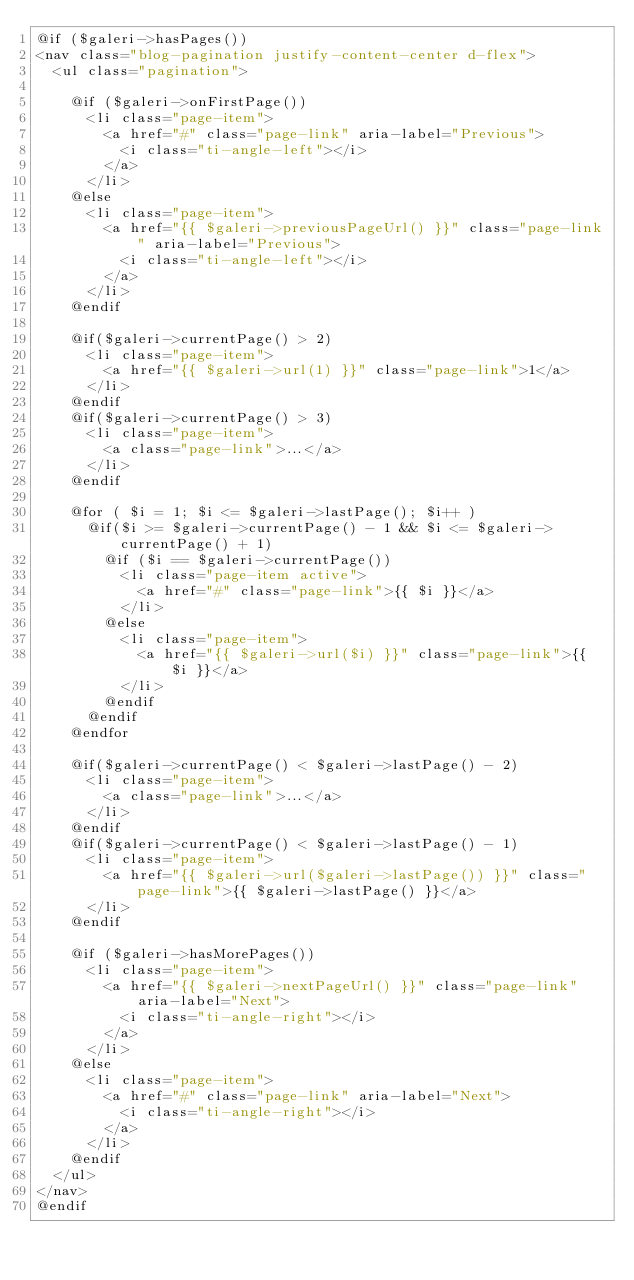<code> <loc_0><loc_0><loc_500><loc_500><_PHP_>@if ($galeri->hasPages())
<nav class="blog-pagination justify-content-center d-flex">
  <ul class="pagination">

    @if ($galeri->onFirstPage())
      <li class="page-item">
        <a href="#" class="page-link" aria-label="Previous">
          <i class="ti-angle-left"></i>
        </a>
      </li>
    @else
      <li class="page-item">
        <a href="{{ $galeri->previousPageUrl() }}" class="page-link" aria-label="Previous">
          <i class="ti-angle-left"></i>
        </a>
      </li>
    @endif

    @if($galeri->currentPage() > 2)
      <li class="page-item">
        <a href="{{ $galeri->url(1) }}" class="page-link">1</a>
      </li>
    @endif
    @if($galeri->currentPage() > 3)
      <li class="page-item">
        <a class="page-link">...</a>
      </li>
    @endif

    @for ( $i = 1; $i <= $galeri->lastPage(); $i++ )
      @if($i >= $galeri->currentPage() - 1 && $i <= $galeri->currentPage() + 1)
        @if ($i == $galeri->currentPage())
          <li class="page-item active">
            <a href="#" class="page-link">{{ $i }}</a>
          </li>
        @else
          <li class="page-item">
            <a href="{{ $galeri->url($i) }}" class="page-link">{{ $i }}</a>
          </li>
        @endif
      @endif
    @endfor

    @if($galeri->currentPage() < $galeri->lastPage() - 2)
      <li class="page-item">
        <a class="page-link">...</a>
      </li>
    @endif
    @if($galeri->currentPage() < $galeri->lastPage() - 1)
      <li class="page-item">
        <a href="{{ $galeri->url($galeri->lastPage()) }}" class="page-link">{{ $galeri->lastPage() }}</a>
      </li>
    @endif

    @if ($galeri->hasMorePages())
      <li class="page-item">
        <a href="{{ $galeri->nextPageUrl() }}" class="page-link" aria-label="Next">
          <i class="ti-angle-right"></i>
        </a>
      </li>
    @else
      <li class="page-item">
        <a href="#" class="page-link" aria-label="Next">
          <i class="ti-angle-right"></i>
        </a>
      </li>
    @endif
  </ul>
</nav>
@endif
</code> 